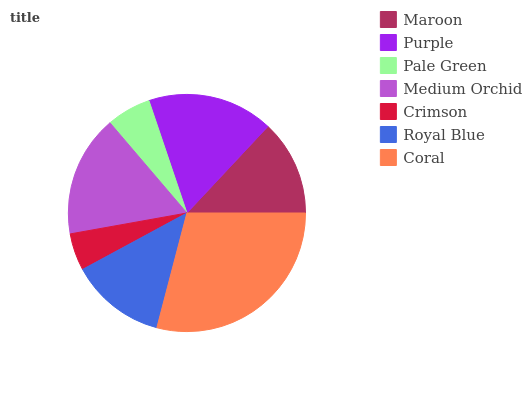Is Crimson the minimum?
Answer yes or no. Yes. Is Coral the maximum?
Answer yes or no. Yes. Is Purple the minimum?
Answer yes or no. No. Is Purple the maximum?
Answer yes or no. No. Is Purple greater than Maroon?
Answer yes or no. Yes. Is Maroon less than Purple?
Answer yes or no. Yes. Is Maroon greater than Purple?
Answer yes or no. No. Is Purple less than Maroon?
Answer yes or no. No. Is Royal Blue the high median?
Answer yes or no. Yes. Is Royal Blue the low median?
Answer yes or no. Yes. Is Medium Orchid the high median?
Answer yes or no. No. Is Medium Orchid the low median?
Answer yes or no. No. 